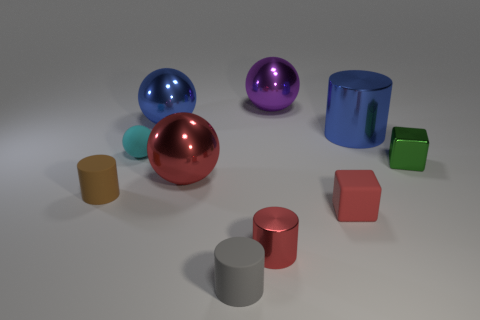Which objects in the image appear to have reflective surfaces? The blue, purple, and red spherical objects along with the large blue cylinder exhibit highly reflective surfaces, mirroring their surroundings with a glossy finish. 